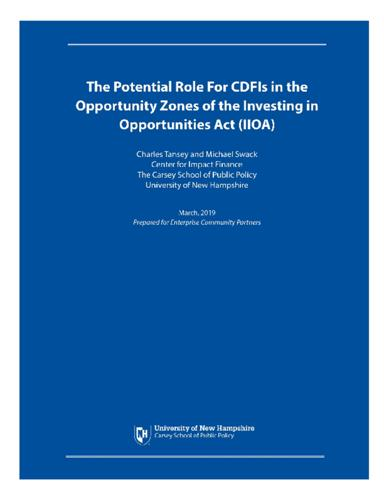Which institute or school is associated with the authors? Charles Tansey and Michael Swack are linked with the University of New Hampshire, specifically through their roles at the Center for Impact Finance at The Carsey School of Public Policy. 